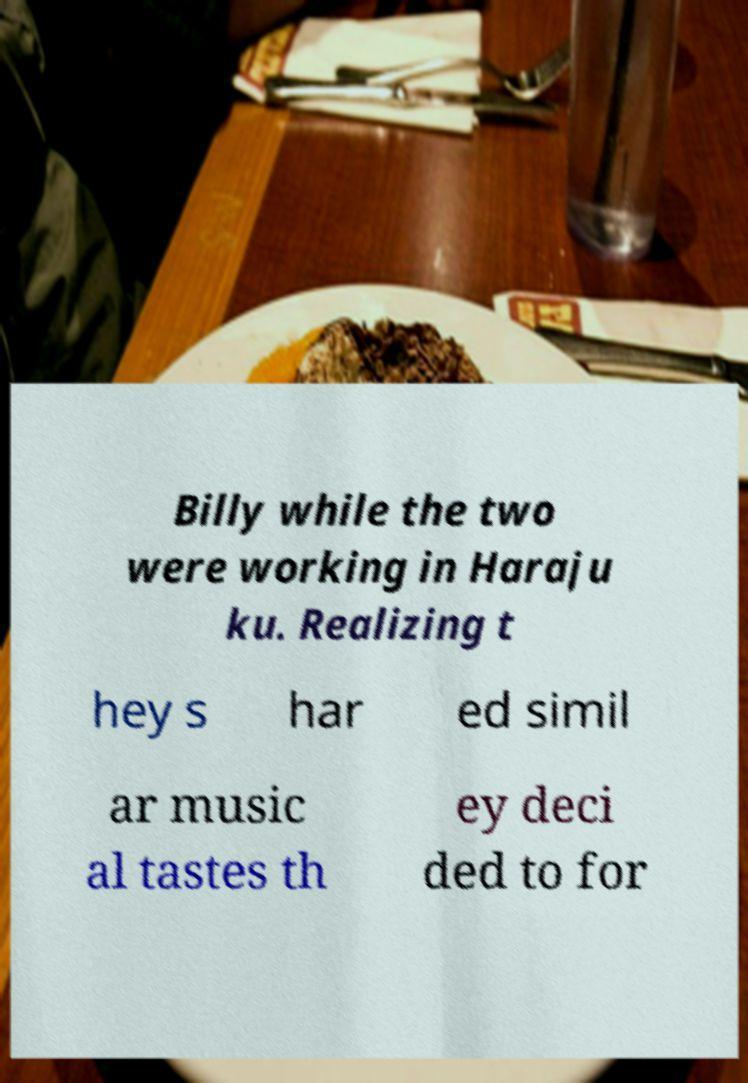Can you read and provide the text displayed in the image?This photo seems to have some interesting text. Can you extract and type it out for me? Billy while the two were working in Haraju ku. Realizing t hey s har ed simil ar music al tastes th ey deci ded to for 